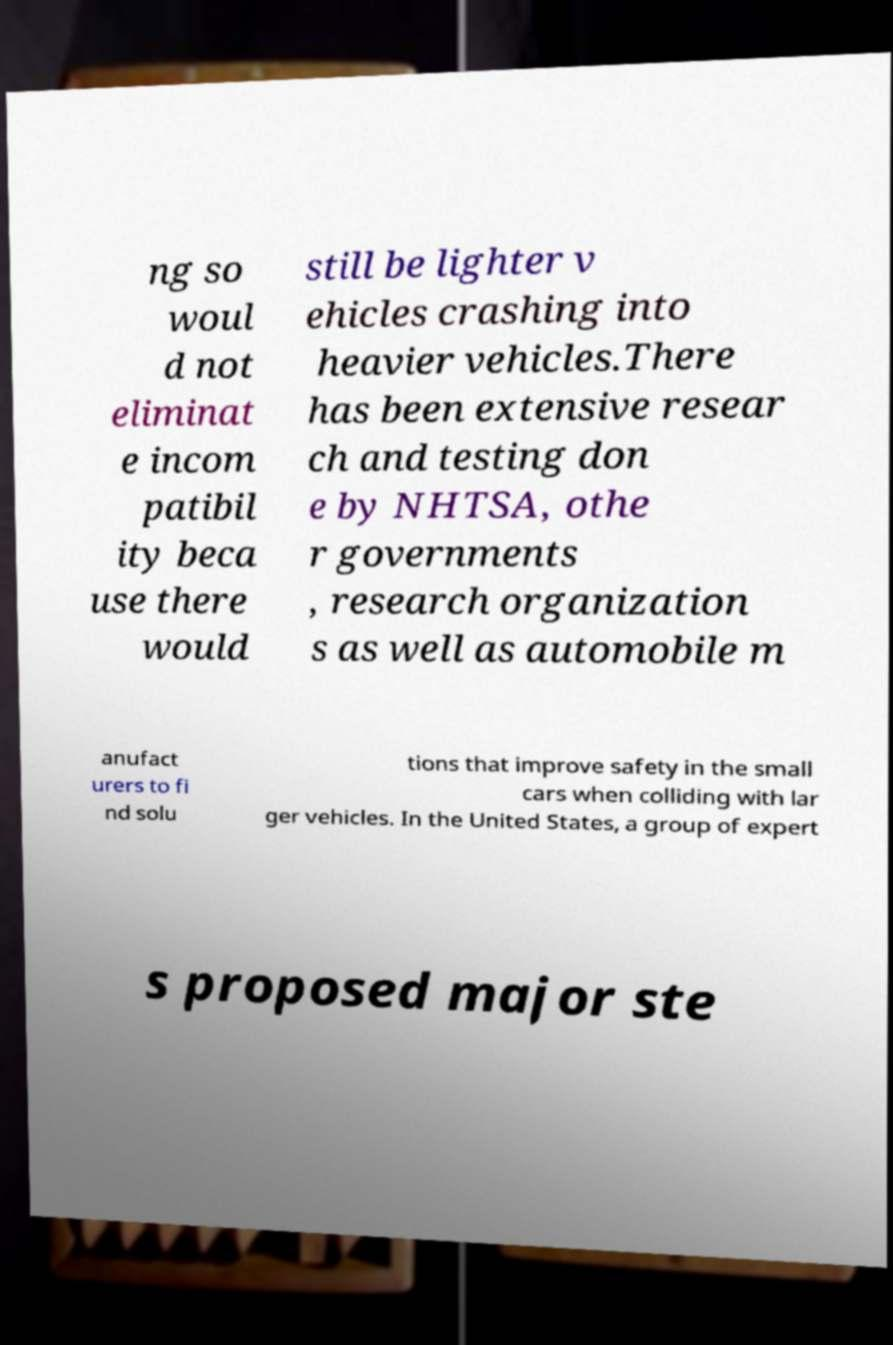For documentation purposes, I need the text within this image transcribed. Could you provide that? ng so woul d not eliminat e incom patibil ity beca use there would still be lighter v ehicles crashing into heavier vehicles.There has been extensive resear ch and testing don e by NHTSA, othe r governments , research organization s as well as automobile m anufact urers to fi nd solu tions that improve safety in the small cars when colliding with lar ger vehicles. In the United States, a group of expert s proposed major ste 